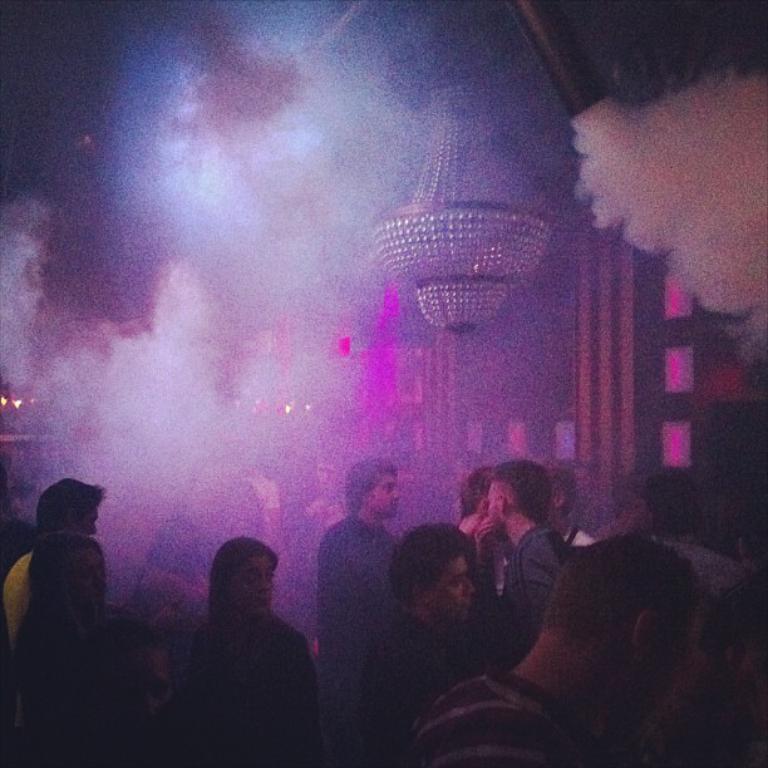Could you give a brief overview of what you see in this image? In this image we can see many people. Behind the persons we can see a wall. At the top we can see the smoke and a chandelier. 